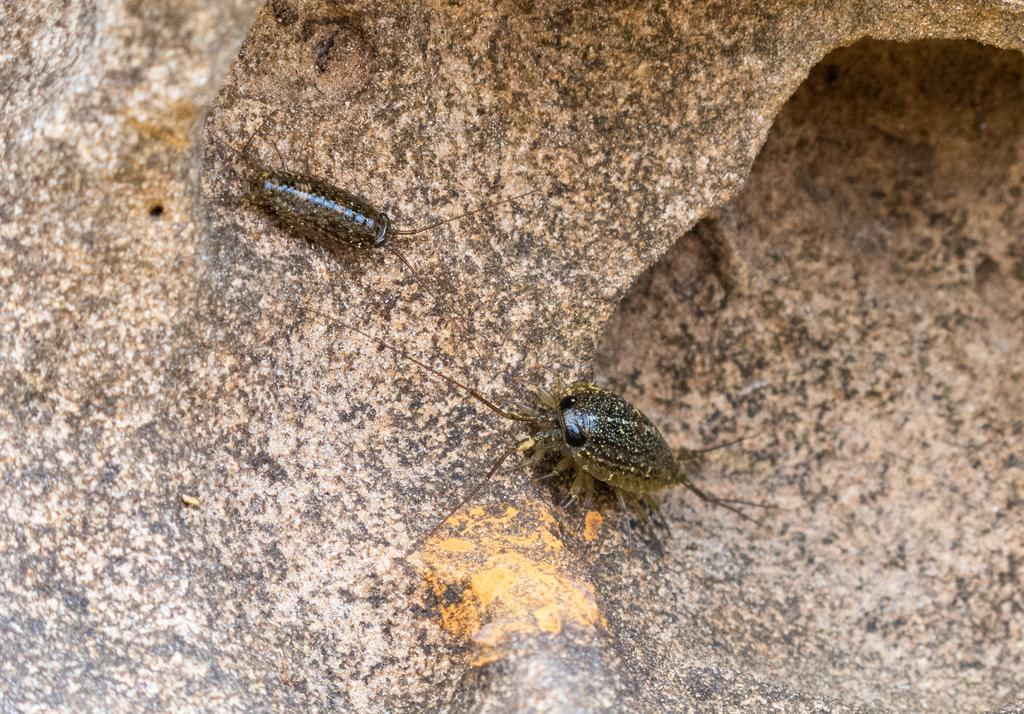How many insects are present in the image? There are two insects in the image. Where are the insects located? The insects are on a rock. What type of farm animals can be seen in the image? There are no farm animals present in the image; it features two insects on a rock. How many people are in the crowd in the image? There is no crowd present in the image; it features two insects on a rock. 